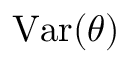<formula> <loc_0><loc_0><loc_500><loc_500>{ V a r } ( \theta )</formula> 